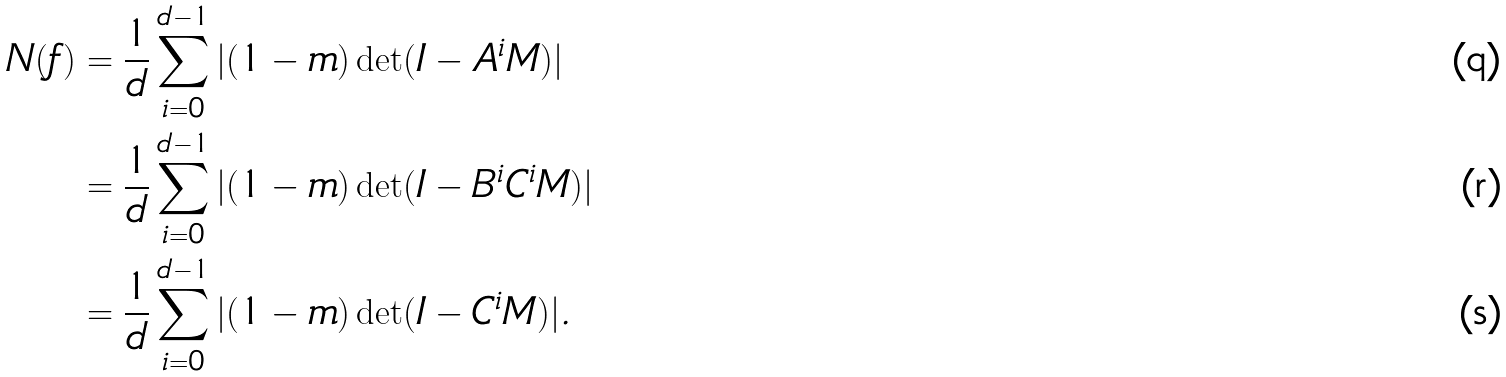Convert formula to latex. <formula><loc_0><loc_0><loc_500><loc_500>N ( f ) & = \frac { 1 } { d } \sum _ { i = 0 } ^ { d - 1 } | ( 1 - m ) \det ( I - A ^ { i } M ) | \\ & = \frac { 1 } { d } \sum _ { i = 0 } ^ { d - 1 } | ( 1 - m ) \det ( I - B ^ { i } C ^ { i } M ) | \\ & = \frac { 1 } { d } \sum _ { i = 0 } ^ { d - 1 } | ( 1 - m ) \det ( I - C ^ { i } M ) | .</formula> 